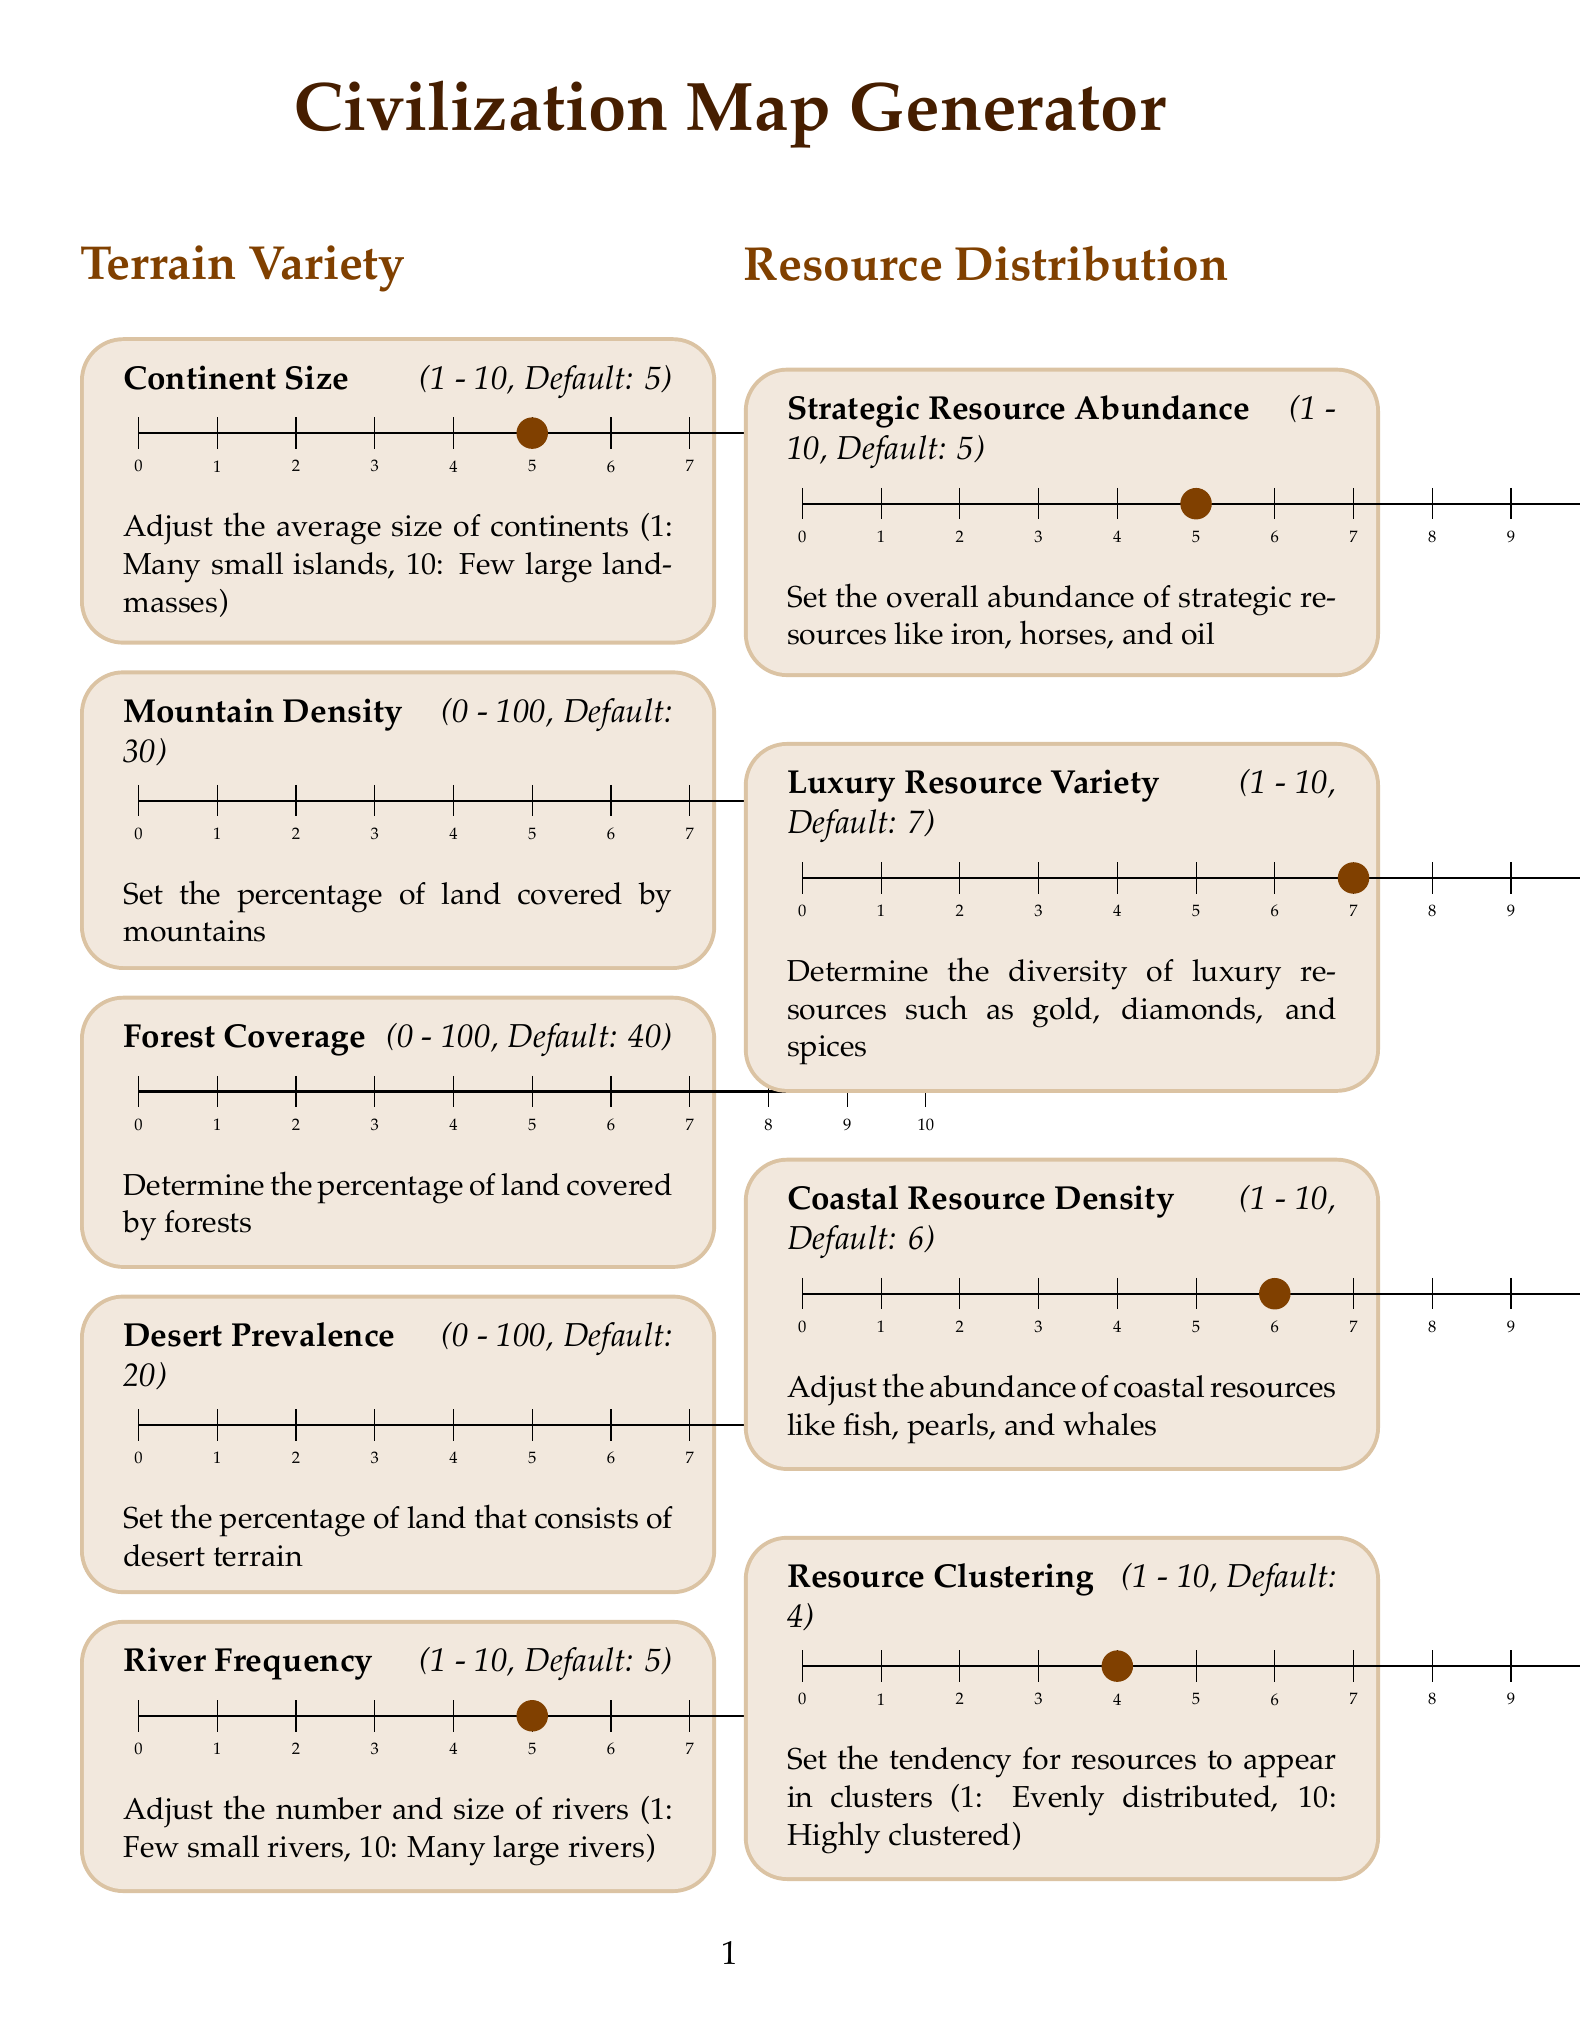What is the maximum value for Mountain Density? The maximum value for Mountain Density is stated in the slider section, which is 100.
Answer: 100 What is the default value for Forest Coverage? The default value for Forest Coverage is provided in the sliders, which is 40.
Answer: 40 What does Pangaea represent? Pangaea is described in the presets section as a single massive continent surrounded by ocean.
Answer: A single massive continent surrounded by ocean What is the minimum value for Coastal Bias? The document specifies that the minimum value for Coastal Bias is 0, as indicated in the slider section.
Answer: 0 What percentage chance is set for starting locations to be near coastlines by default? The default percentage chance for starting locations being on or near coastlines is explicitly defined in the sliders as 50.
Answer: 50 Which setting determines the abundance of strategic resources? The setting determining the abundance of strategic resources is named Strategic Resource Abundance in the Resource Distribution section.
Answer: Strategic Resource Abundance What is the default value for Natural Wonder Frequency? The default value for Natural Wonder Frequency is indicated in the Advanced Options section, which is 7.
Answer: 7 What is the number of distinct Climate Zones by default? The default number of distinct Climate Zones is mentioned in the Advanced Options sliders, which is 3.
Answer: 3 